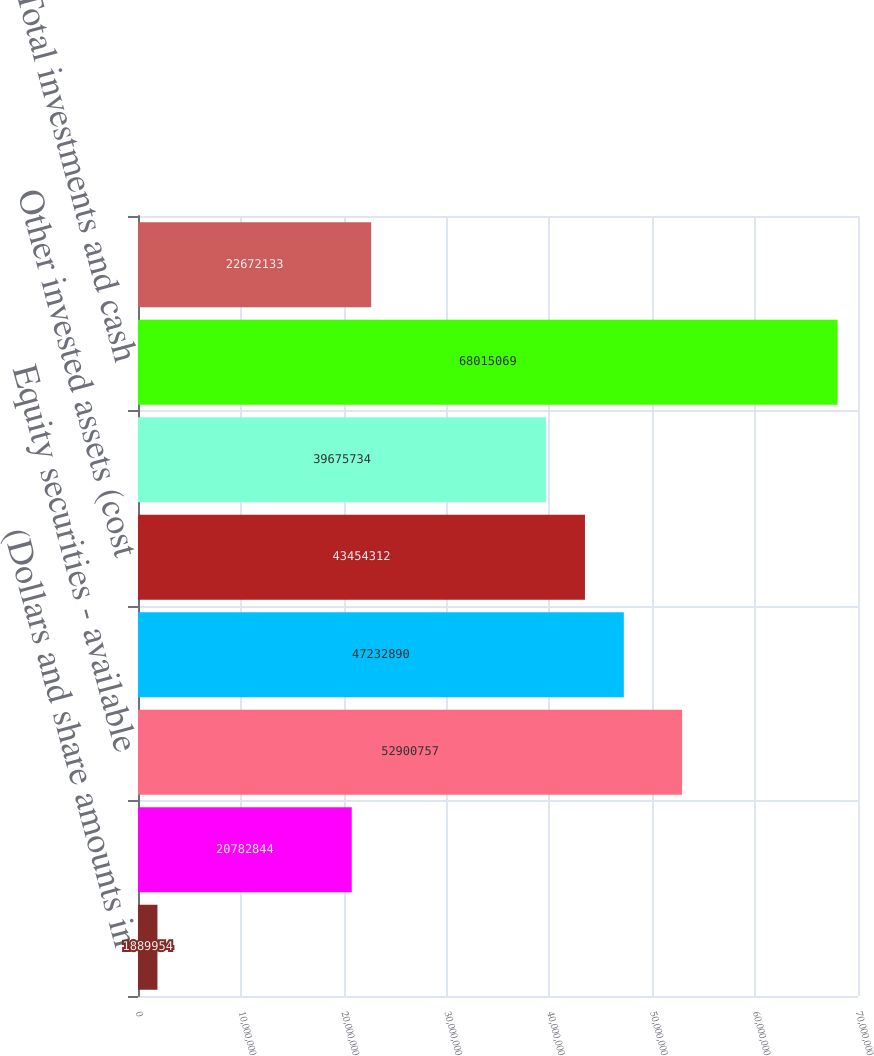Convert chart. <chart><loc_0><loc_0><loc_500><loc_500><bar_chart><fcel>(Dollars and share amounts in<fcel>Fixed maturities - available<fcel>Equity securities - available<fcel>Short-term investments<fcel>Other invested assets (cost<fcel>Cash<fcel>Total investments and cash<fcel>Accrued investment income<nl><fcel>1.88995e+06<fcel>2.07828e+07<fcel>5.29008e+07<fcel>4.72329e+07<fcel>4.34543e+07<fcel>3.96757e+07<fcel>6.80151e+07<fcel>2.26721e+07<nl></chart> 